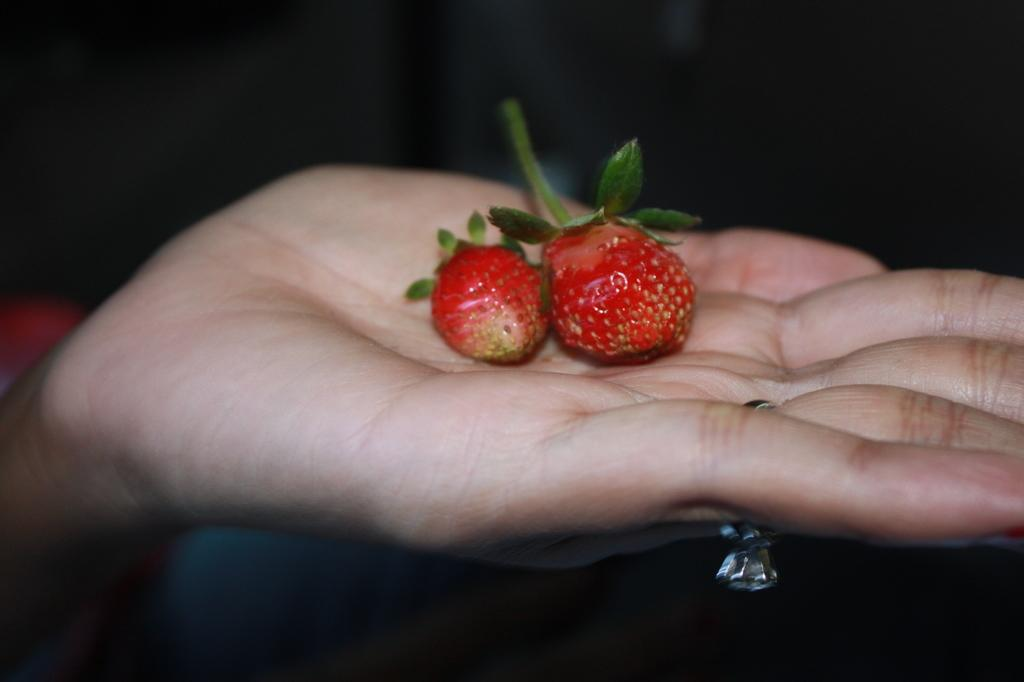What can be seen in the image? There is a person's hand in the image. What is on the hand? There are two strawberries on the hand. What type of mint is being used to light the match in the image? There is no mint or match present in the image; it only features a person's hand with two strawberries on it. 